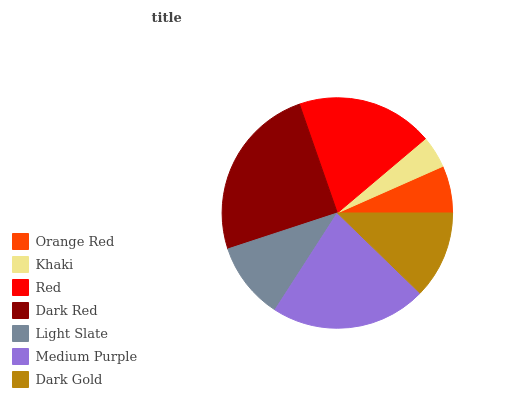Is Khaki the minimum?
Answer yes or no. Yes. Is Dark Red the maximum?
Answer yes or no. Yes. Is Red the minimum?
Answer yes or no. No. Is Red the maximum?
Answer yes or no. No. Is Red greater than Khaki?
Answer yes or no. Yes. Is Khaki less than Red?
Answer yes or no. Yes. Is Khaki greater than Red?
Answer yes or no. No. Is Red less than Khaki?
Answer yes or no. No. Is Dark Gold the high median?
Answer yes or no. Yes. Is Dark Gold the low median?
Answer yes or no. Yes. Is Dark Red the high median?
Answer yes or no. No. Is Dark Red the low median?
Answer yes or no. No. 